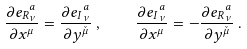<formula> <loc_0><loc_0><loc_500><loc_500>\frac { \partial { e _ { R } } _ { \nu } ^ { a } } { \partial x ^ { \mu } } = \frac { \partial { e _ { I } } _ { \nu } ^ { a } } { \partial y ^ { \check { \mu } } } \, , \quad \frac { \partial { e _ { I } } _ { \nu } ^ { a } } { \partial x ^ { \mu } } = - \frac { \partial { e _ { R } } _ { \nu } ^ { a } } { \partial y ^ { \check { \mu } } } \, .</formula> 